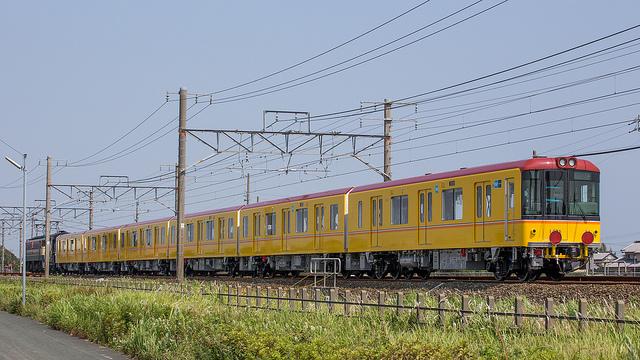What color is the train?
Short answer required. Yellow. Is the train long?
Answer briefly. Yes. Is this a passenger train?
Keep it brief. Yes. Is this in the city?
Short answer required. No. Is there graffiti on the train?
Write a very short answer. No. 